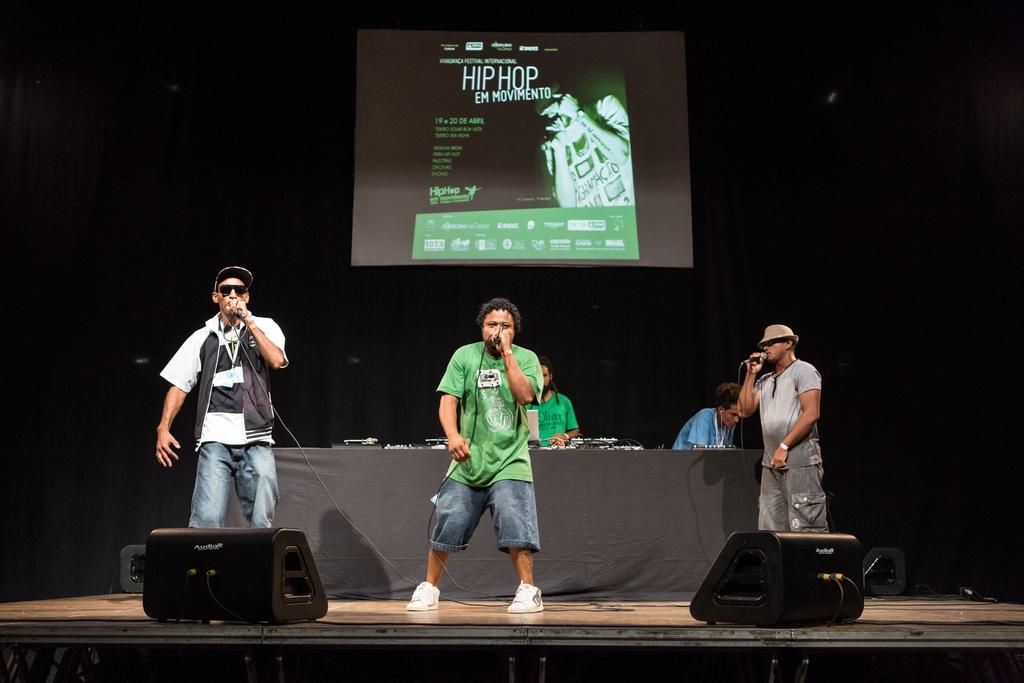What are the people on stage doing in the image? There are 3 people on the stage singing in the image. What can be seen behind the people on stage? There is a table and a screen behind the people on stage. Who is near the table in the image? There are two people near the table in the image. What can be seen in the front of the stage? There are two lights in the front of the stage. Can you see a snail crawling on the stage in the image? No, there is no snail present in the image. What type of underwear are the people on stage wearing in the image? There is no information about the underwear of the people on stage in the image. 